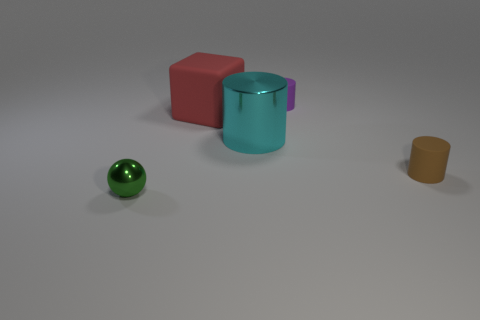Subtract all small brown rubber cylinders. How many cylinders are left? 2 Add 4 large green metallic spheres. How many objects exist? 9 Subtract all cyan cylinders. How many cylinders are left? 2 Subtract all cylinders. How many objects are left? 2 Add 1 small cylinders. How many small cylinders exist? 3 Subtract 0 red balls. How many objects are left? 5 Subtract all green cylinders. Subtract all blue cubes. How many cylinders are left? 3 Subtract all large blue rubber cylinders. Subtract all big matte blocks. How many objects are left? 4 Add 4 purple cylinders. How many purple cylinders are left? 5 